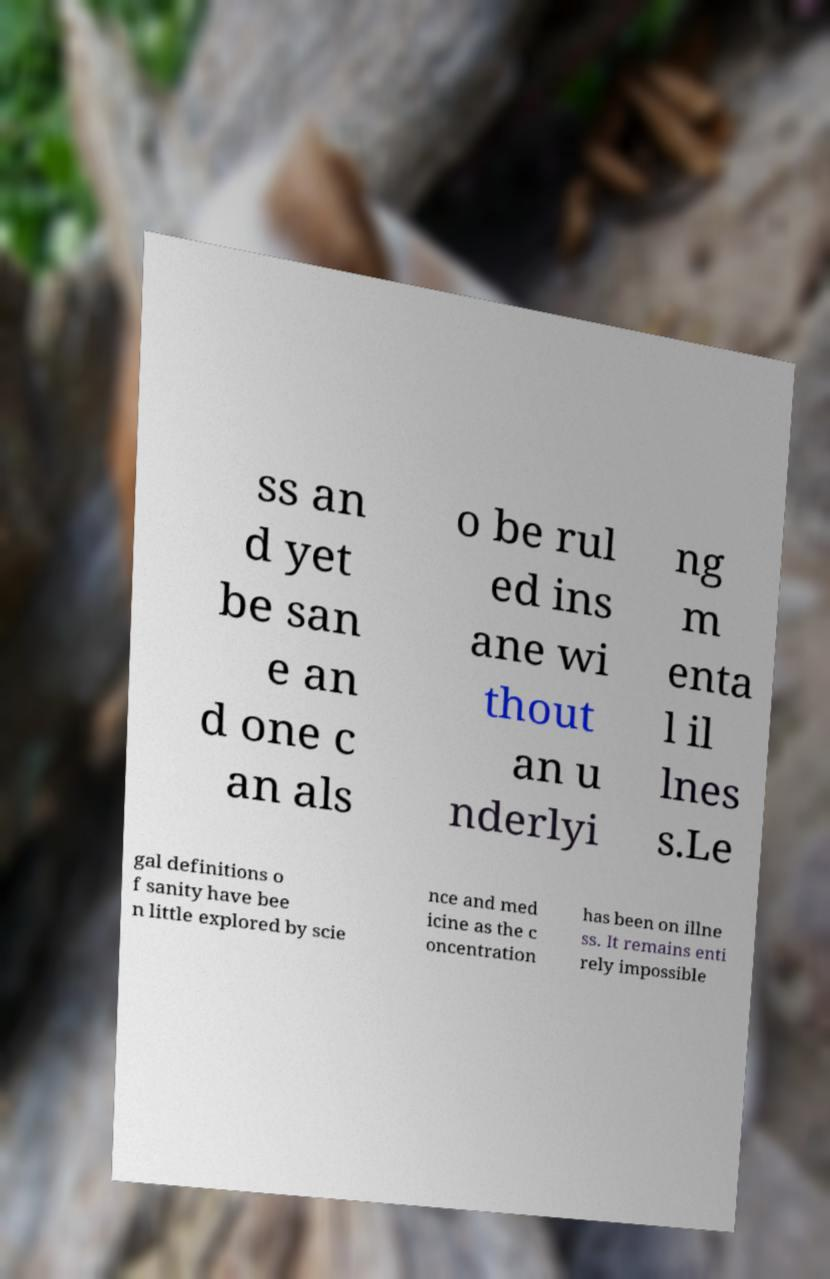What messages or text are displayed in this image? I need them in a readable, typed format. ss an d yet be san e an d one c an als o be rul ed ins ane wi thout an u nderlyi ng m enta l il lnes s.Le gal definitions o f sanity have bee n little explored by scie nce and med icine as the c oncentration has been on illne ss. It remains enti rely impossible 